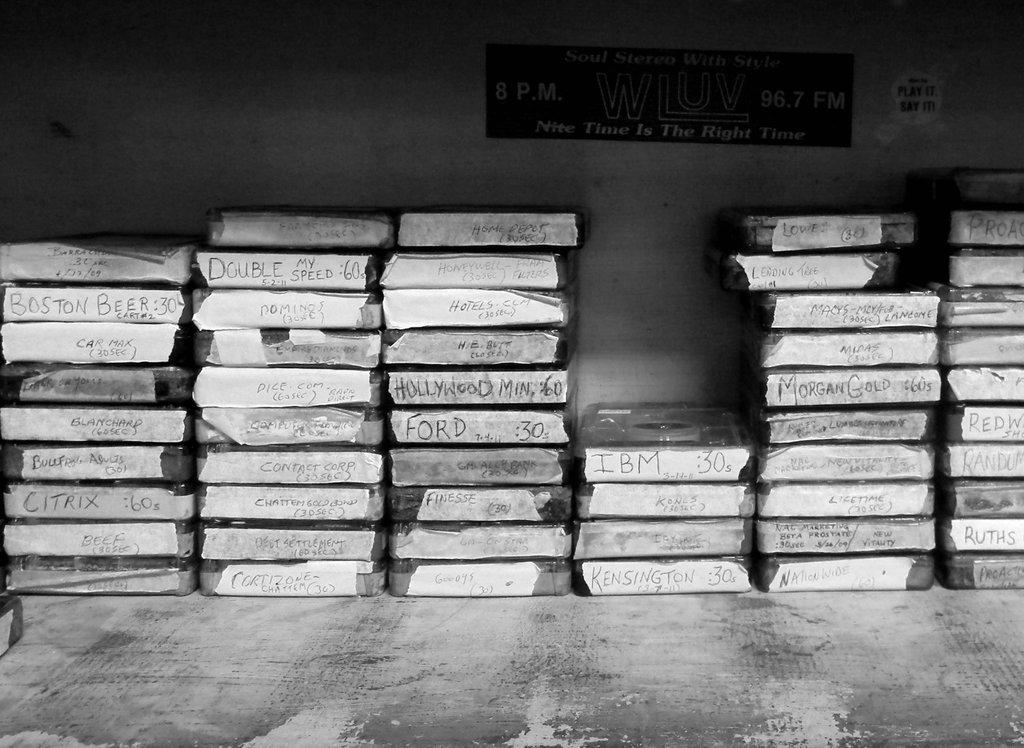<image>
Summarize the visual content of the image. stacks of objects with one of them labeled 'ford' 